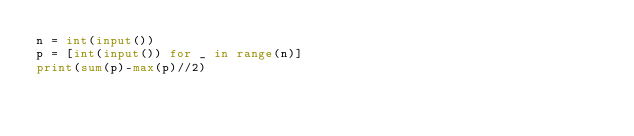Convert code to text. <code><loc_0><loc_0><loc_500><loc_500><_Python_>n = int(input())
p = [int(input()) for _ in range(n)]
print(sum(p)-max(p)//2)</code> 